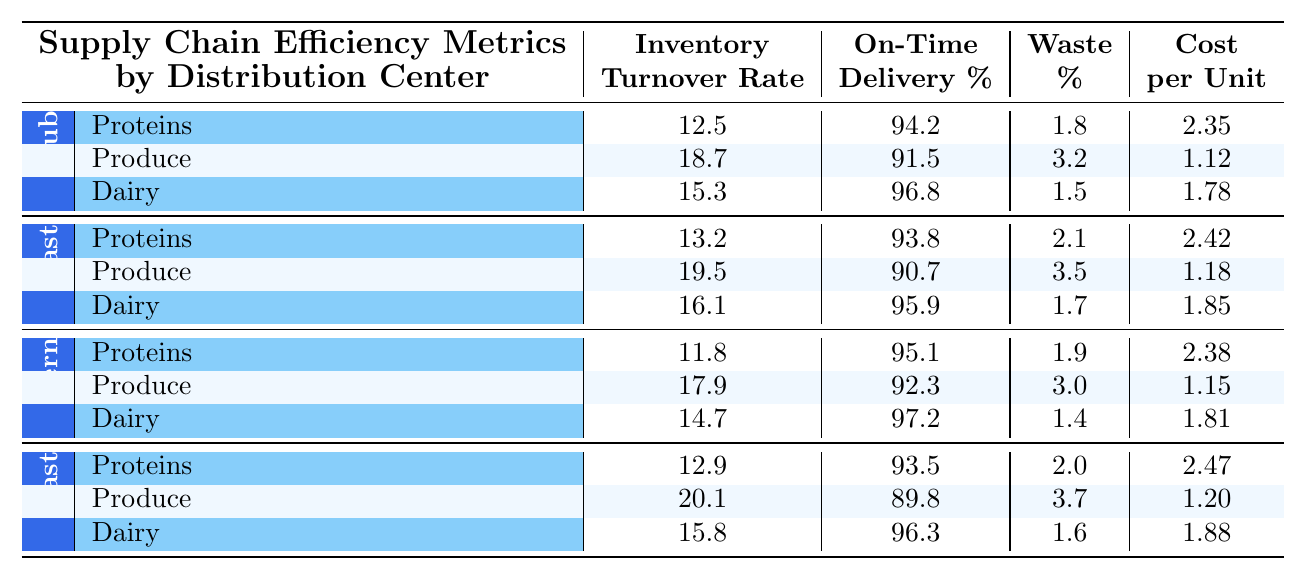What is the Inventory Turnover Rate for Produce at the Midwest Hub? The table shows that the Inventory Turnover Rate for Produce in the Midwest Hub is specifically listed as 18.7.
Answer: 18.7 Which distribution center has the highest On-Time Delivery percentage for Dairy? By comparing the On-Time Delivery percentages for Dairy across all distribution centers, the Southern Depot has the highest percentage at 97.2.
Answer: Southern Depot What is the average cost per unit for Proteins across all distribution centers? The costs per unit for Proteins are: 2.35 (Midwest Hub), 2.42 (East Coast), 2.38 (Southern Depot), and 2.47 (West Coast). The total cost is 2.35 + 2.42 + 2.38 + 2.47 = 9.62, and the average is 9.62 / 4 = 2.405.
Answer: 2.405 Is Produce categorized waste percentage higher than 3% in any distribution center? Checking the Waste percentages for Produce, the Midwest Hub has 3.2%, East Coast has 3.5%, Southern Depot has 3.0%, and West Coast has 3.7%. Since all except Southern Depot exceed 3%, the answer is yes.
Answer: Yes Which food category has the lowest Waste percentage at the East Coast Center? Looking at the Waste percentages for all categories at the East Coast Center, Dairy has the lowest at 1.7%, while Proteins is 2.1% and Produce is 3.5%.
Answer: Dairy Calculate the difference in Inventory Turnover Rate for Dairy between the Midwest Hub and the Southern Depot. The Inventory Turnover Rate for Dairy at the Midwest Hub is 15.3, and at the Southern Depot, it is 14.7. The difference can be calculated as 15.3 - 14.7 = 0.6.
Answer: 0.6 Which distribution center has the highest Inventory Turnover Rate for Produce, and what is that rate? The table indicates that the highest Inventory Turnover Rate for Produce is at the West Coast Facility, which has a rate of 20.1.
Answer: West Coast Facility, 20.1 Are the On-Time Delivery percentages for Dairy over 95% in all distribution centers? Checking the On-Time Delivery percentages for Dairy: Midwest Hub (96.8), East Coast (95.9), Southern Depot (97.2), and West Coast (96.3), all these values are indeed over 95%.
Answer: Yes What is the combined Inventory Turnover Rate for all food categories at the Southern Depot? The Inventory Turnover Rates for all categories at Southern Depot are: Proteins (11.8), Produce (17.9), and Dairy (14.7). The total is 11.8 + 17.9 + 14.7 = 44.4.
Answer: 44.4 Which food category has the highest cost per unit at the West Coast Facility? The costs per unit for each food category at the West Coast Facility are: Proteins (2.47), Produce (1.20), and Dairy (1.88). The highest is Proteins at 2.47.
Answer: Proteins 